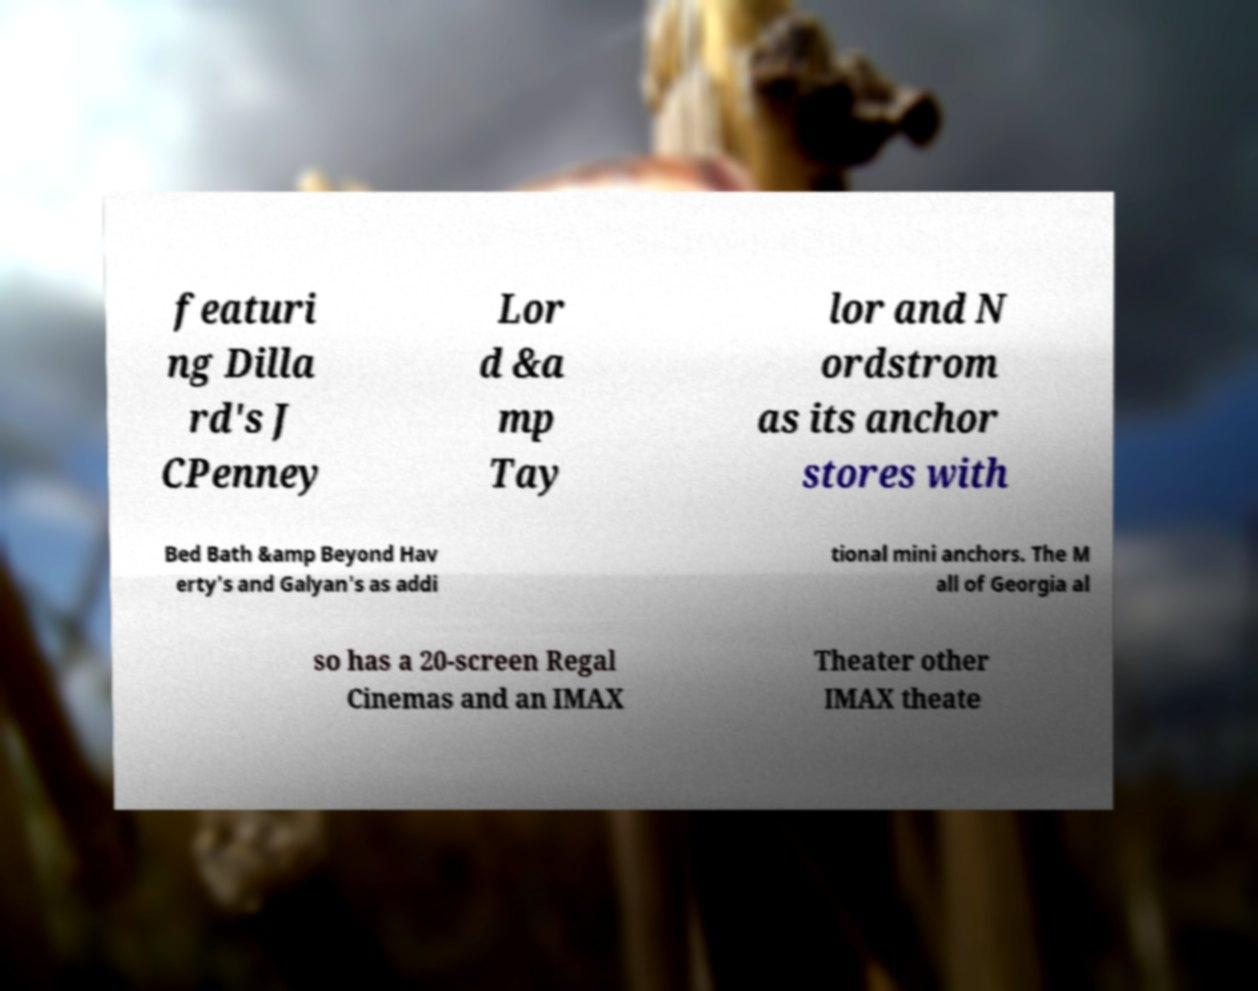For documentation purposes, I need the text within this image transcribed. Could you provide that? featuri ng Dilla rd's J CPenney Lor d &a mp Tay lor and N ordstrom as its anchor stores with Bed Bath &amp Beyond Hav erty's and Galyan's as addi tional mini anchors. The M all of Georgia al so has a 20-screen Regal Cinemas and an IMAX Theater other IMAX theate 